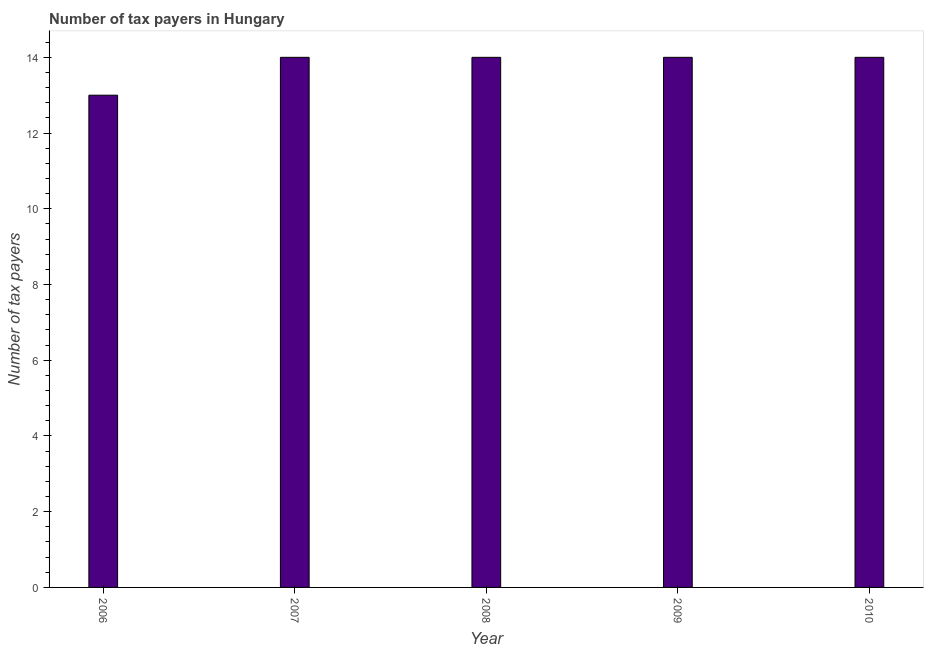What is the title of the graph?
Ensure brevity in your answer.  Number of tax payers in Hungary. What is the label or title of the Y-axis?
Your answer should be very brief. Number of tax payers. What is the number of tax payers in 2006?
Keep it short and to the point. 13. Across all years, what is the maximum number of tax payers?
Give a very brief answer. 14. Across all years, what is the minimum number of tax payers?
Provide a succinct answer. 13. In which year was the number of tax payers maximum?
Keep it short and to the point. 2007. What is the difference between the number of tax payers in 2007 and 2009?
Offer a terse response. 0. What is the median number of tax payers?
Make the answer very short. 14. Is the number of tax payers in 2007 less than that in 2009?
Make the answer very short. No. Is the difference between the number of tax payers in 2008 and 2010 greater than the difference between any two years?
Keep it short and to the point. No. What is the difference between the highest and the second highest number of tax payers?
Make the answer very short. 0. How many bars are there?
Your answer should be compact. 5. How many years are there in the graph?
Offer a very short reply. 5. What is the Number of tax payers of 2006?
Your answer should be very brief. 13. What is the Number of tax payers of 2010?
Provide a succinct answer. 14. What is the difference between the Number of tax payers in 2006 and 2007?
Ensure brevity in your answer.  -1. What is the difference between the Number of tax payers in 2007 and 2008?
Provide a succinct answer. 0. What is the difference between the Number of tax payers in 2007 and 2010?
Provide a succinct answer. 0. What is the difference between the Number of tax payers in 2008 and 2009?
Offer a terse response. 0. What is the difference between the Number of tax payers in 2008 and 2010?
Your answer should be compact. 0. What is the ratio of the Number of tax payers in 2006 to that in 2007?
Provide a short and direct response. 0.93. What is the ratio of the Number of tax payers in 2006 to that in 2008?
Provide a succinct answer. 0.93. What is the ratio of the Number of tax payers in 2006 to that in 2009?
Offer a very short reply. 0.93. What is the ratio of the Number of tax payers in 2006 to that in 2010?
Make the answer very short. 0.93. What is the ratio of the Number of tax payers in 2007 to that in 2010?
Give a very brief answer. 1. What is the ratio of the Number of tax payers in 2008 to that in 2009?
Your answer should be very brief. 1. What is the ratio of the Number of tax payers in 2008 to that in 2010?
Offer a terse response. 1. What is the ratio of the Number of tax payers in 2009 to that in 2010?
Ensure brevity in your answer.  1. 